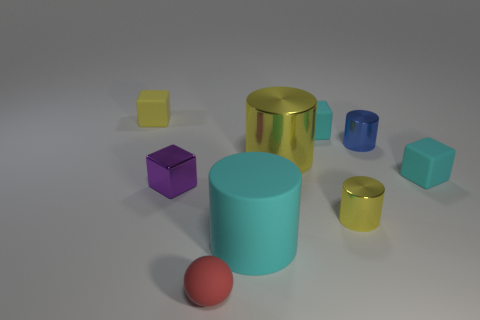Does the large metal cylinder have the same color as the big rubber object?
Ensure brevity in your answer.  No. There is a tiny rubber thing that is both right of the matte cylinder and on the left side of the small yellow metal thing; what is its color?
Give a very brief answer. Cyan. How many objects are tiny metallic things right of the purple metal object or tiny red spheres?
Provide a short and direct response. 3. What is the color of the tiny shiny thing that is the same shape as the yellow rubber thing?
Your answer should be very brief. Purple. There is a blue shiny thing; does it have the same shape as the tiny yellow object that is right of the tiny yellow rubber object?
Give a very brief answer. Yes. How many things are either small rubber objects that are to the left of the small purple cube or rubber objects behind the cyan cylinder?
Your answer should be compact. 3. Is the number of small yellow metal cylinders on the left side of the small red rubber sphere less than the number of big metallic cylinders?
Your answer should be compact. Yes. Do the small blue object and the small yellow object that is on the left side of the small purple object have the same material?
Ensure brevity in your answer.  No. What material is the sphere?
Provide a short and direct response. Rubber. What material is the cyan block on the left side of the tiny yellow object that is right of the rubber thing on the left side of the small red thing?
Make the answer very short. Rubber. 